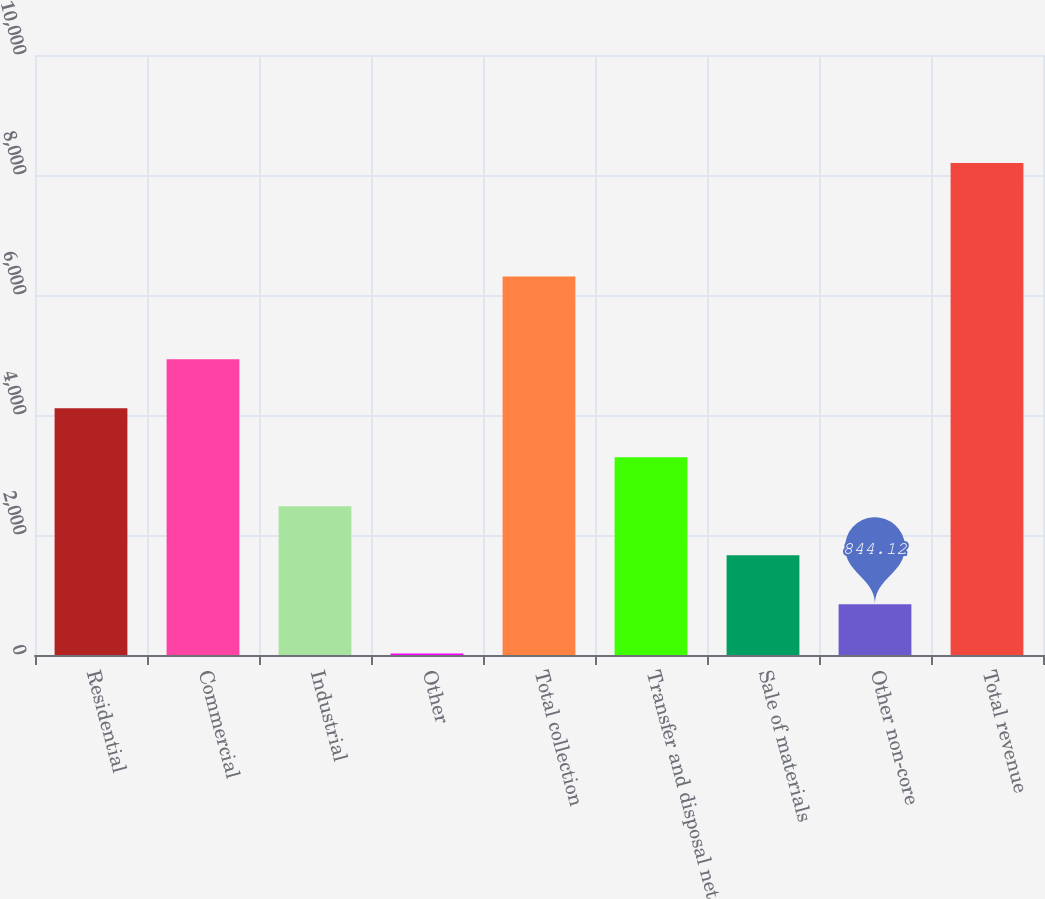Convert chart. <chart><loc_0><loc_0><loc_500><loc_500><bar_chart><fcel>Residential<fcel>Commercial<fcel>Industrial<fcel>Other<fcel>Total collection<fcel>Transfer and disposal net<fcel>Sale of materials<fcel>Other non-core<fcel>Total revenue<nl><fcel>4113<fcel>4930.22<fcel>2478.56<fcel>26.9<fcel>6308.7<fcel>3295.78<fcel>1661.34<fcel>844.12<fcel>8199.1<nl></chart> 